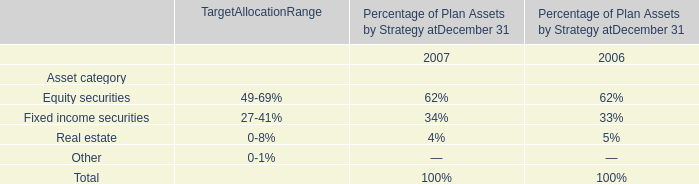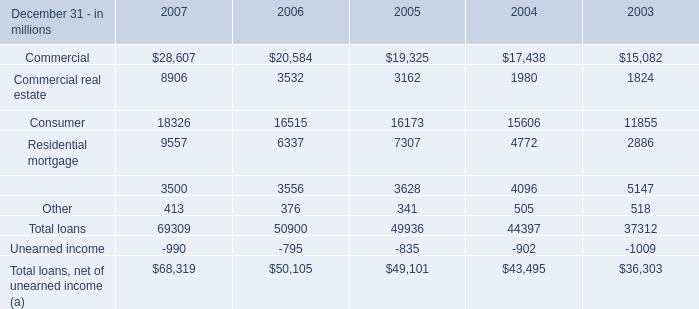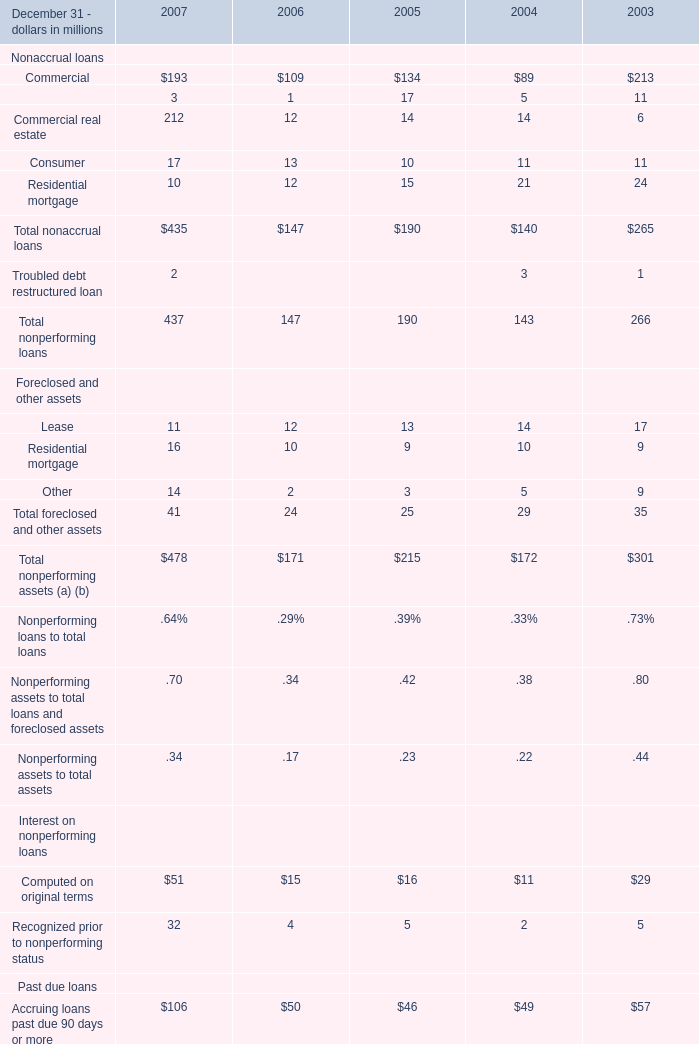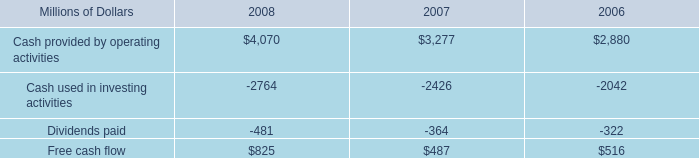what was the percentage change in free cash flow from 2007 to 2008? 
Computations: ((825 - 487) / 487)
Answer: 0.69405. 